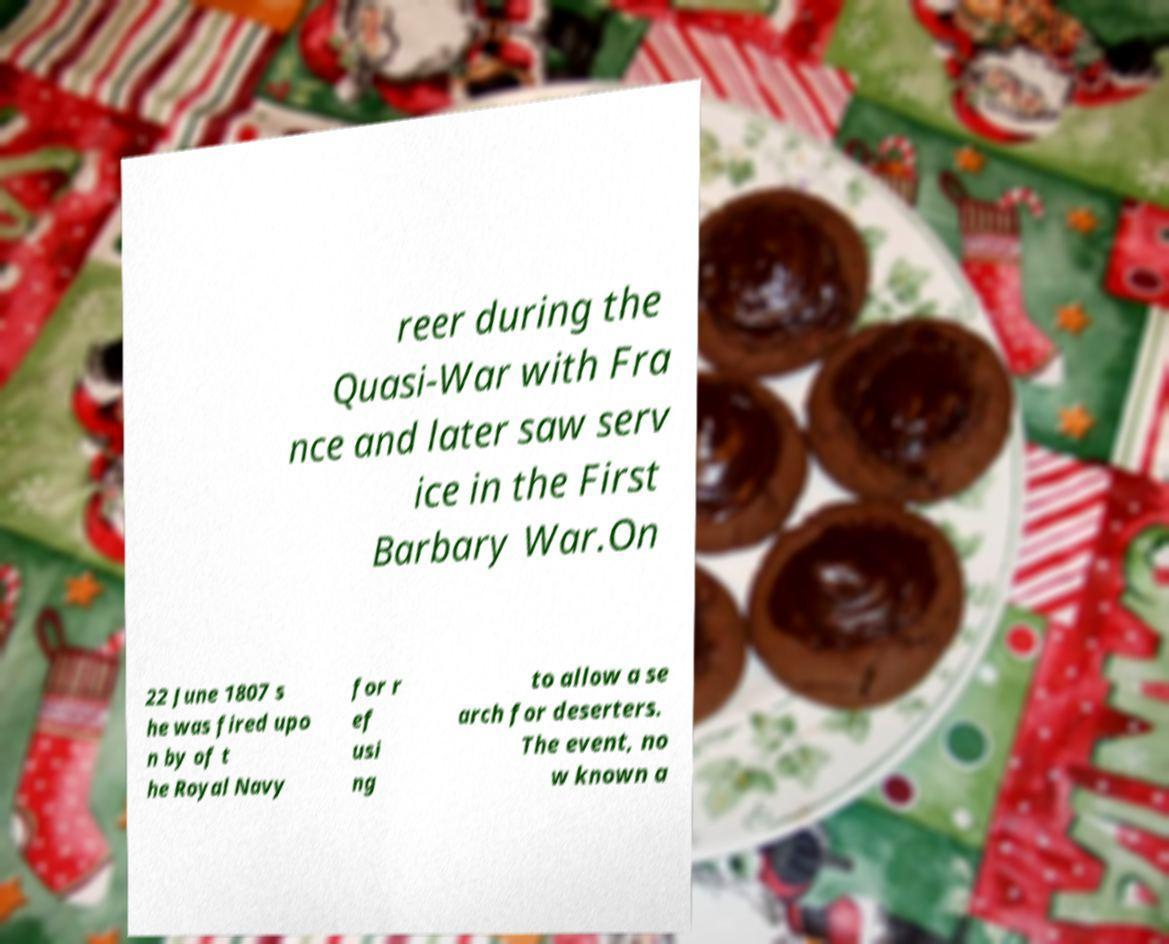Could you extract and type out the text from this image? reer during the Quasi-War with Fra nce and later saw serv ice in the First Barbary War.On 22 June 1807 s he was fired upo n by of t he Royal Navy for r ef usi ng to allow a se arch for deserters. The event, no w known a 